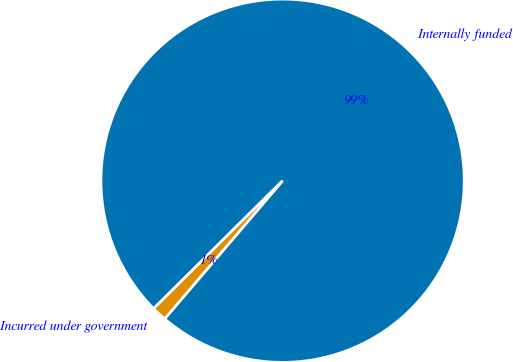Convert chart. <chart><loc_0><loc_0><loc_500><loc_500><pie_chart><fcel>Internally funded<fcel>Incurred under government<nl><fcel>98.68%<fcel>1.32%<nl></chart> 